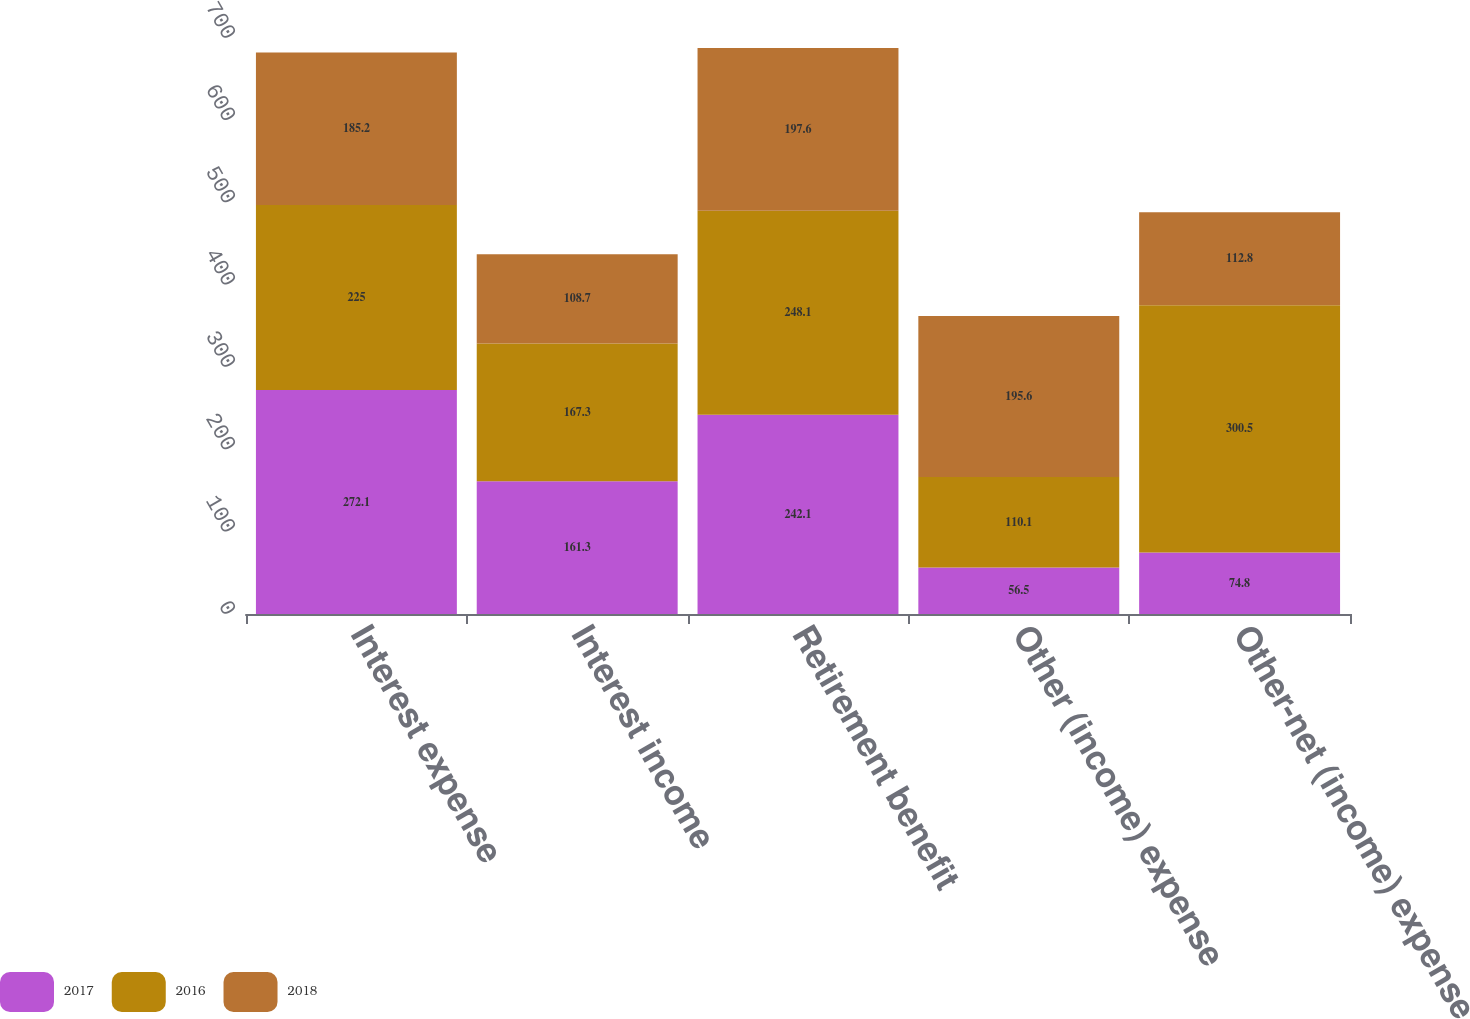Convert chart to OTSL. <chart><loc_0><loc_0><loc_500><loc_500><stacked_bar_chart><ecel><fcel>Interest expense<fcel>Interest income<fcel>Retirement benefit<fcel>Other (income) expense<fcel>Other-net (income) expense<nl><fcel>2017<fcel>272.1<fcel>161.3<fcel>242.1<fcel>56.5<fcel>74.8<nl><fcel>2016<fcel>225<fcel>167.3<fcel>248.1<fcel>110.1<fcel>300.5<nl><fcel>2018<fcel>185.2<fcel>108.7<fcel>197.6<fcel>195.6<fcel>112.8<nl></chart> 